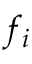Convert formula to latex. <formula><loc_0><loc_0><loc_500><loc_500>f _ { i }</formula> 